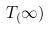<formula> <loc_0><loc_0><loc_500><loc_500>T _ { ( } \infty )</formula> 